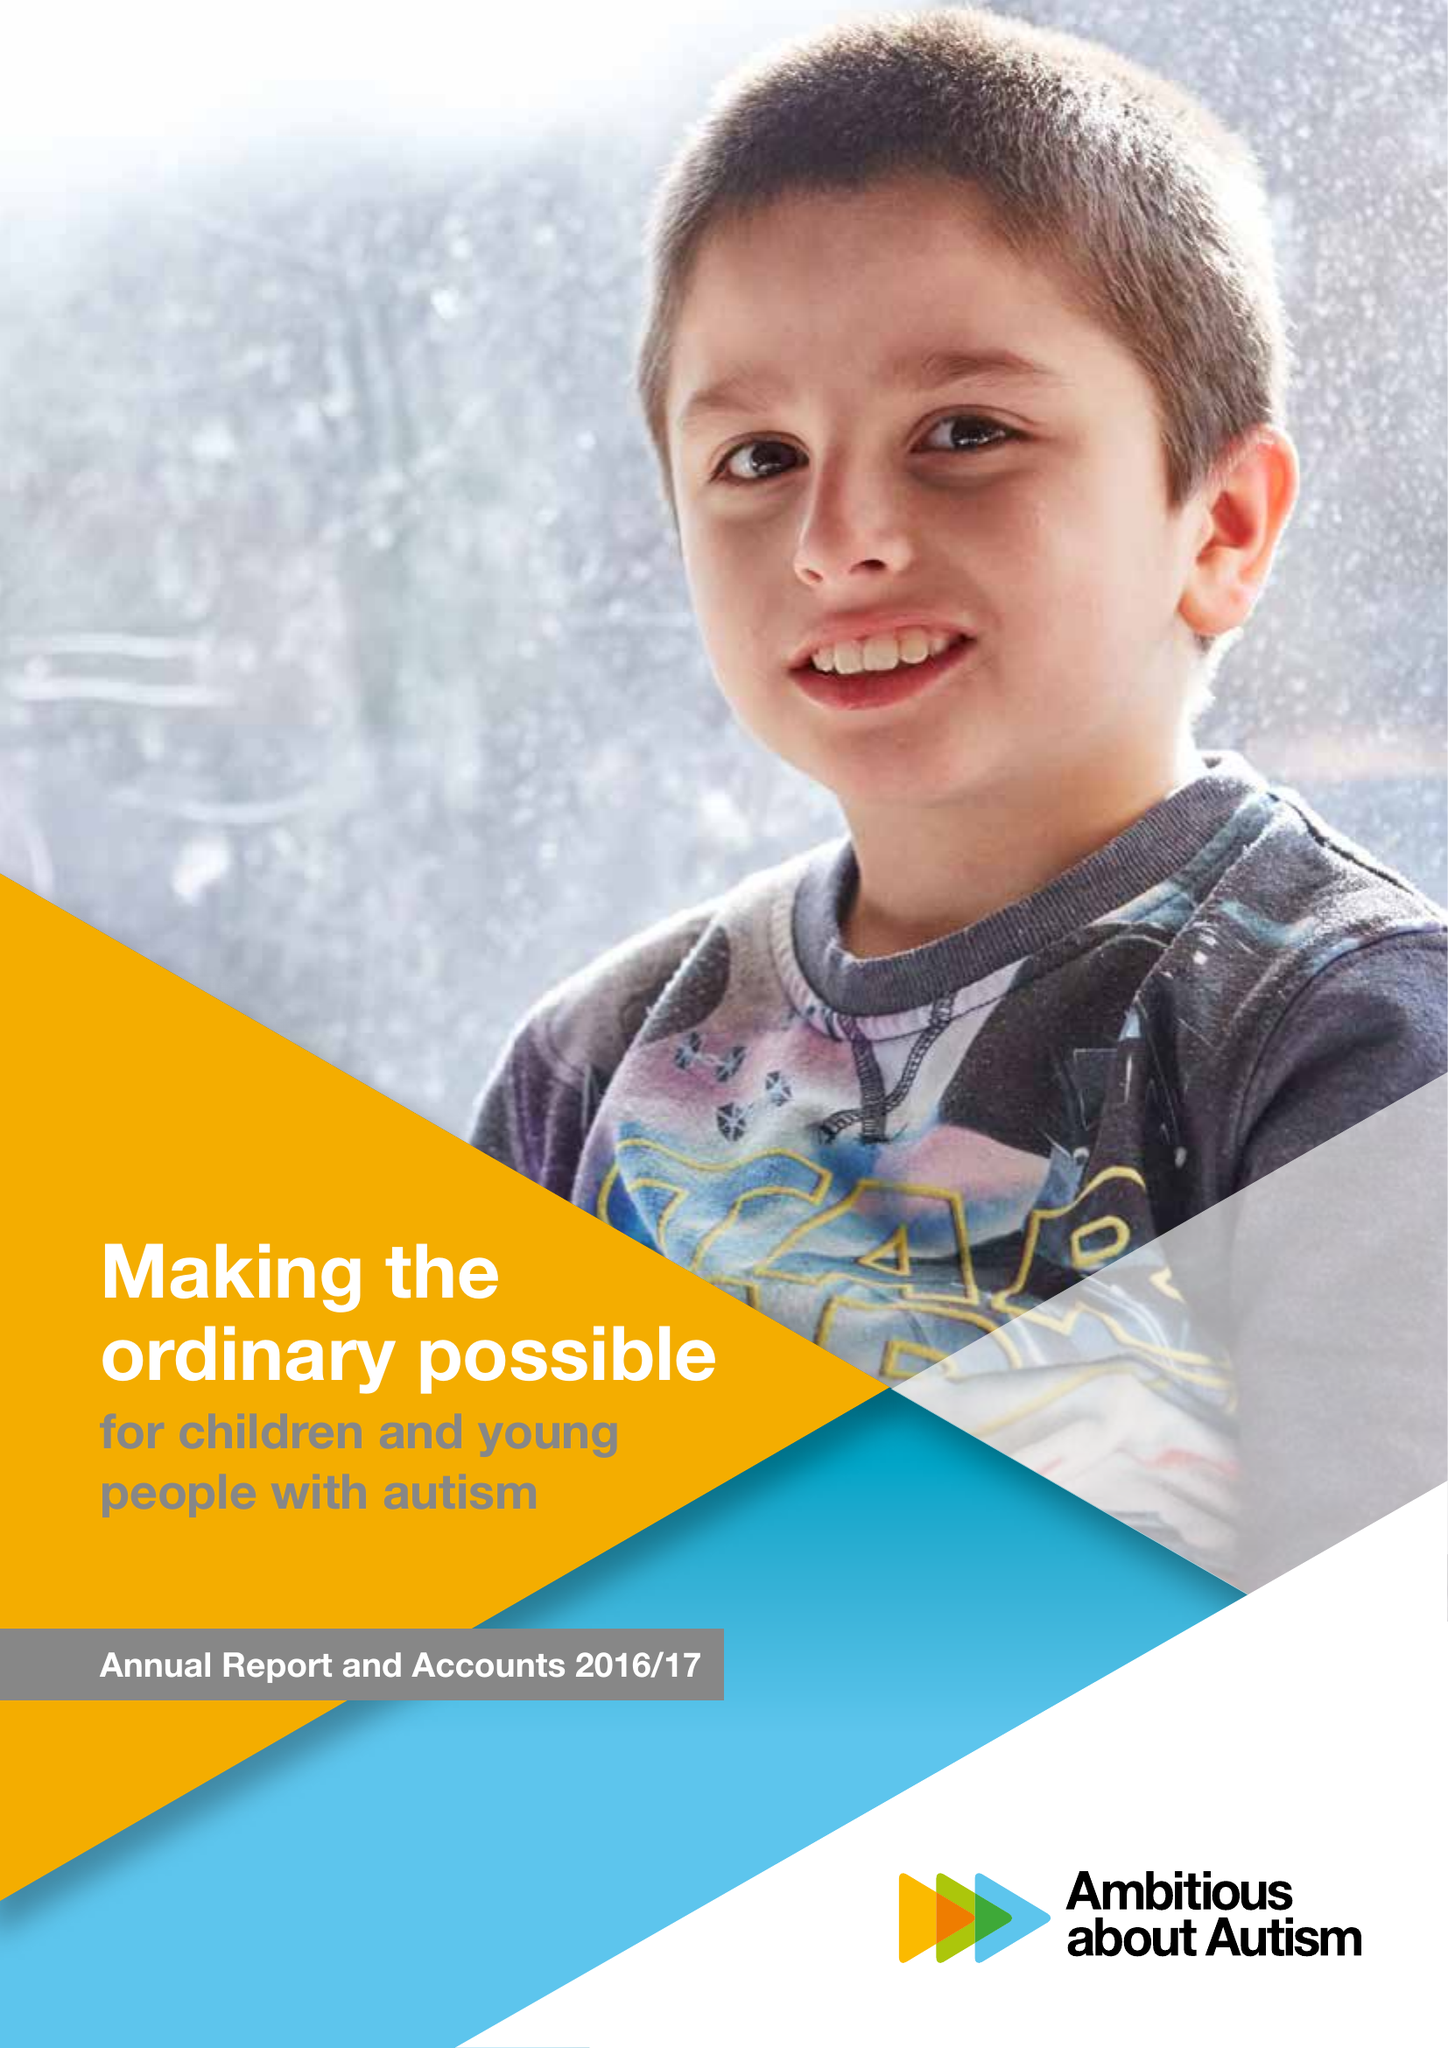What is the value for the spending_annually_in_british_pounds?
Answer the question using a single word or phrase. 17883000.00 